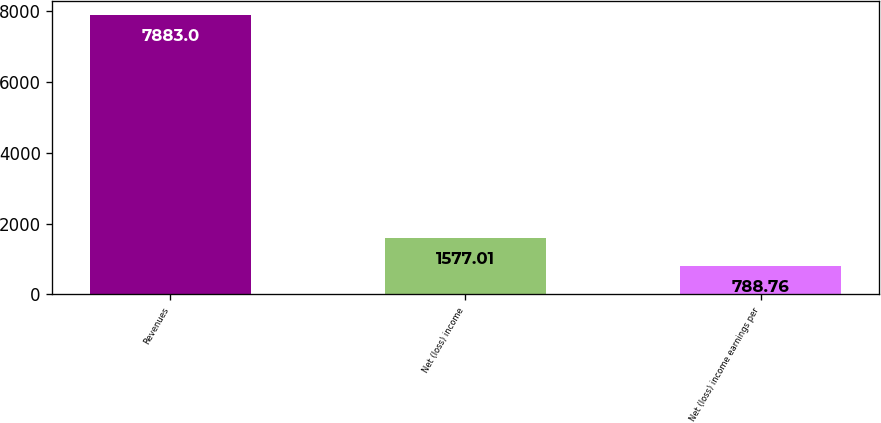<chart> <loc_0><loc_0><loc_500><loc_500><bar_chart><fcel>Revenues<fcel>Net (loss) income<fcel>Net (loss) income earnings per<nl><fcel>7883<fcel>1577.01<fcel>788.76<nl></chart> 